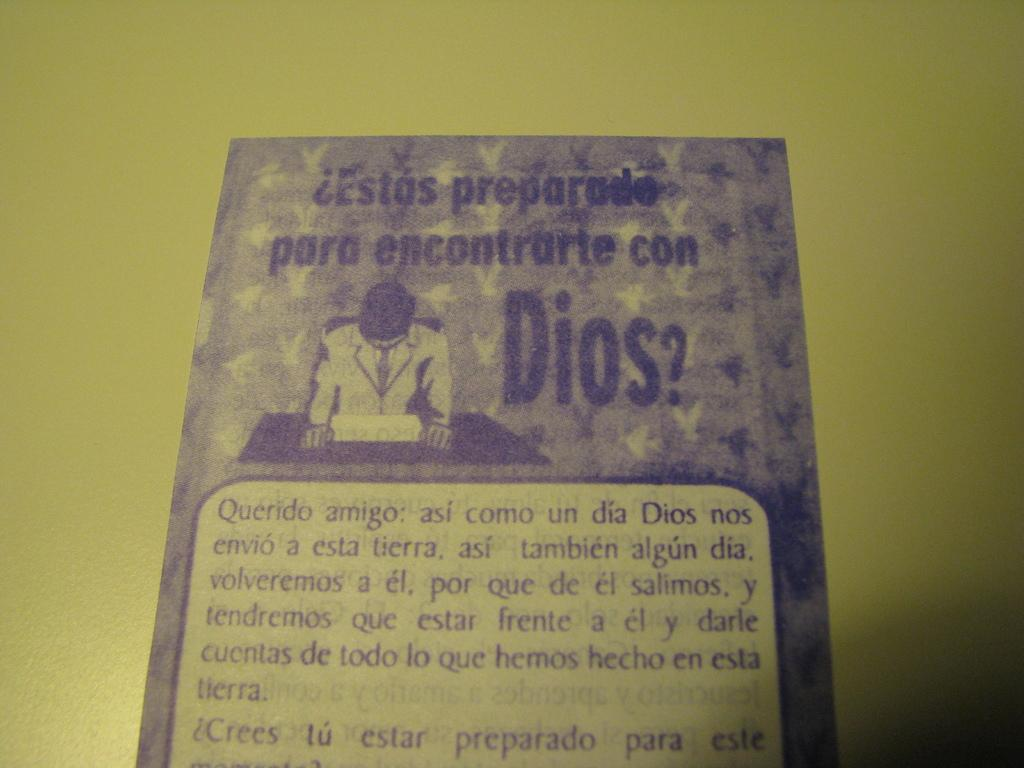Provide a one-sentence caption for the provided image. A piece of paper that shows a man looking down and all the wording is in spanish. 